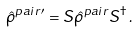Convert formula to latex. <formula><loc_0><loc_0><loc_500><loc_500>\hat { \rho } ^ { p a i r \prime } = S \hat { \rho } ^ { p a i r } S ^ { \dag } \, .</formula> 